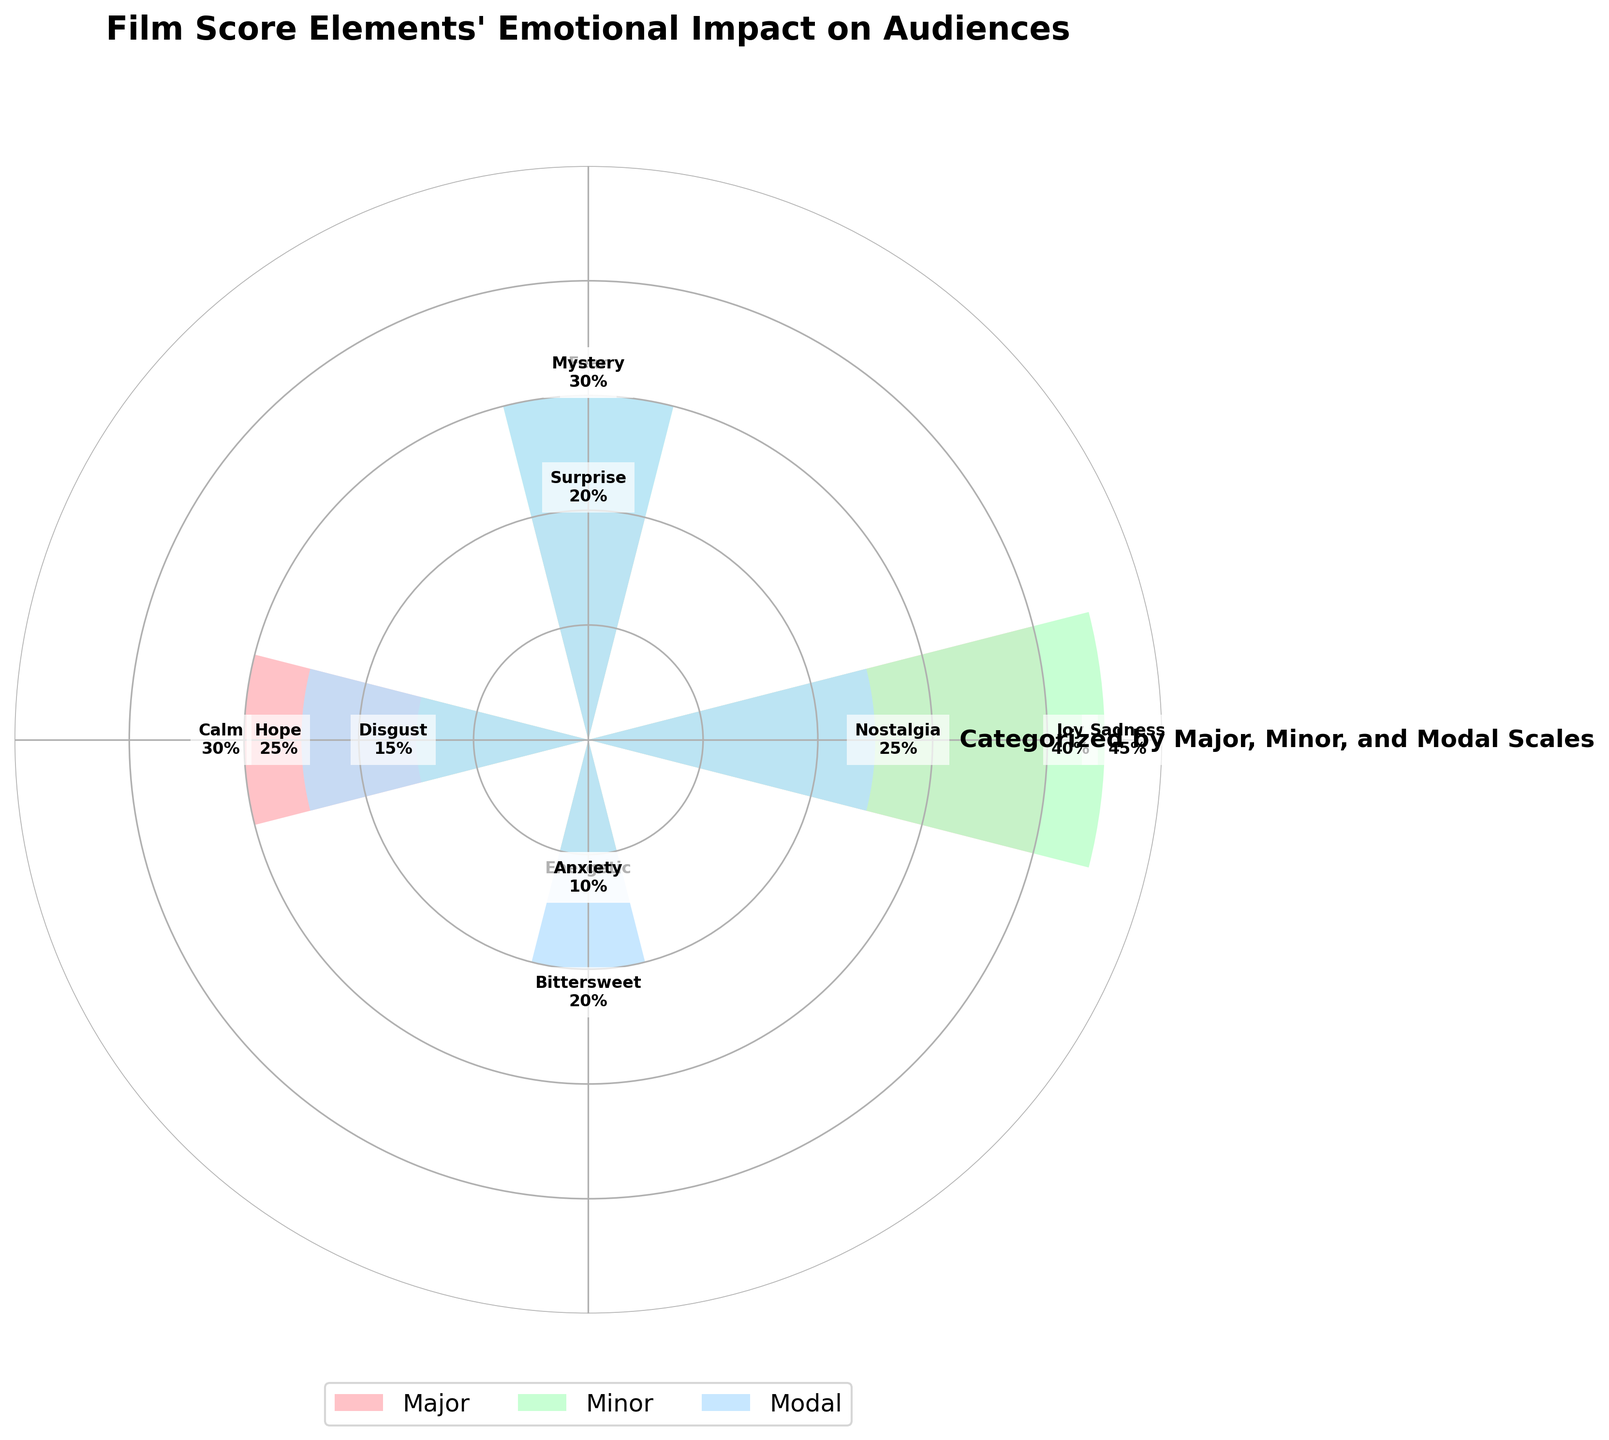What is the title of the figure? The title is located at the top of the figure and provides a summary of what the figure represents.
Answer: Film Score Elements' Emotional Impact on Audiences Which emotion is associated with the highest percentage within the Major scale? Within the Major scale, the emotion with the highest percentage has the largest bar, which reaches 40%. The text label indicates the emotion.
Answer: Joy What is the combined emotional impact percentage for Surprise and Calm in the Major scale? Add the percentage of Surprise (20%) and Calm (30%) in the Major scale.
Answer: 50% Which emotion in the Minor scale has the smallest impact percentage? Within the Minor scale, the smallest bar is the one representing the emotion with the smallest percentage. The text label indicates the emotion.
Answer: Anxiety Compare the emotional impact of Nostalgia in the Modal scale to Joy in the Major scale. Which one has a higher percentage? Check the bars for Nostalgia in Modal (25%) and Joy in Major (40%) and compare their heights.
Answer: Joy What is the average emotional impact percentage of Modal scale emotions? Add the percentage of all emotions in the Modal scale (25% + 30% + 25% + 20%), then divide by the number of emotions (4).
Answer: 25% Which scale has the most diversified emotional impact, meaning more evenly distributed percentages across its emotions? Compare the distribution across Major, Minor, and Modal scales. The scale with the least variation among values (closest to uniform distribution) is the most diversified.
Answer: Modal How many emotions are represented within the Minor scale? Count the number of unique bar segments within the Minor scale category.
Answer: Four Which emotion in the Modal scale has the highest percentage, and what is that percentage? The highest bar in the Modal scale indicates the emotion with the highest percentage. The text label provides the percentage.
Answer: Mystery, 30% What is the ratio of Sadness to Hope in terms of their percentage impact? Divide the percentage impact of Sadness in the Minor scale (45%) by that of Hope in the Modal scale (25%).
Answer: 1.8 